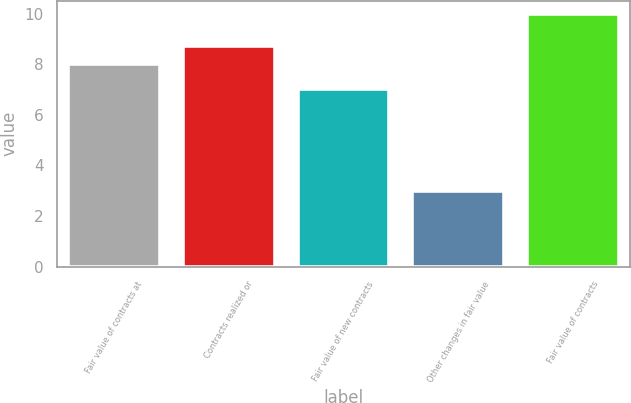Convert chart to OTSL. <chart><loc_0><loc_0><loc_500><loc_500><bar_chart><fcel>Fair value of contracts at<fcel>Contracts realized or<fcel>Fair value of new contracts<fcel>Other changes in fair value<fcel>Fair value of contracts<nl><fcel>8<fcel>8.7<fcel>7<fcel>3<fcel>10<nl></chart> 